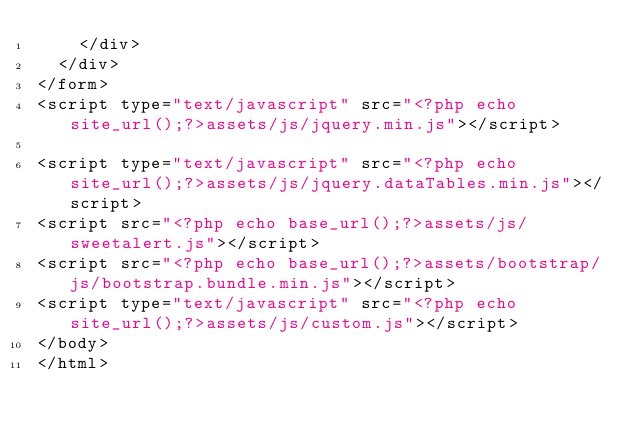Convert code to text. <code><loc_0><loc_0><loc_500><loc_500><_PHP_>    </div>
  </div>
</form>
<script type="text/javascript" src="<?php echo site_url();?>assets/js/jquery.min.js"></script> 

<script type="text/javascript" src="<?php echo site_url();?>assets/js/jquery.dataTables.min.js"></script> 
<script src="<?php echo base_url();?>assets/js/sweetalert.js"></script>
<script src="<?php echo base_url();?>assets/bootstrap/js/bootstrap.bundle.min.js"></script>
<script type="text/javascript" src="<?php echo site_url();?>assets/js/custom.js"></script> 
</body>
</html>
</code> 